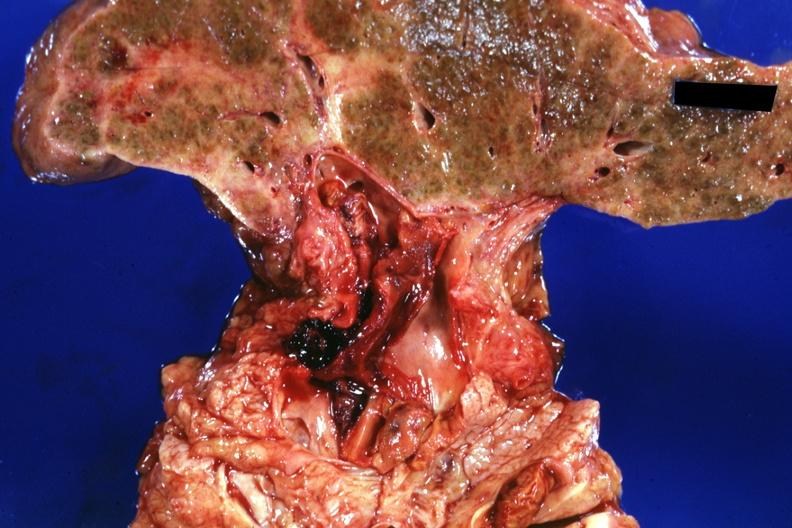s hepatobiliary present?
Answer the question using a single word or phrase. Yes 